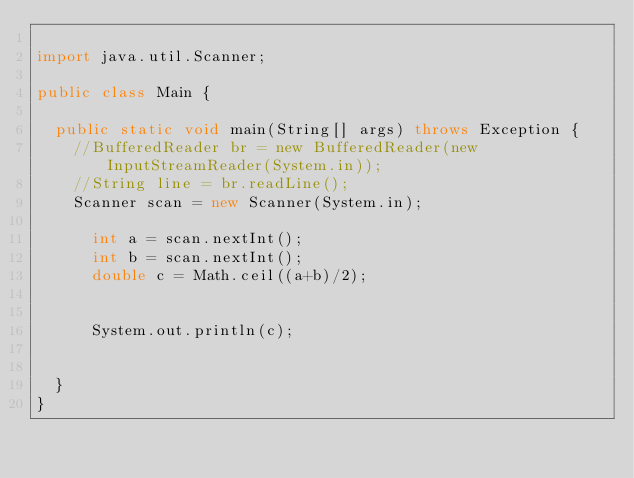<code> <loc_0><loc_0><loc_500><loc_500><_Java_>
import java.util.Scanner;

public class Main {

	public static void main(String[] args) throws Exception {
		//BufferedReader br = new BufferedReader(new InputStreamReader(System.in));
		//String line = br.readLine();
		Scanner scan = new Scanner(System.in);

	    int a = scan.nextInt();
	    int b = scan.nextInt();
	    double c = Math.ceil((a+b)/2);
	    
	    
	    System.out.println(c);


	}
}
</code> 